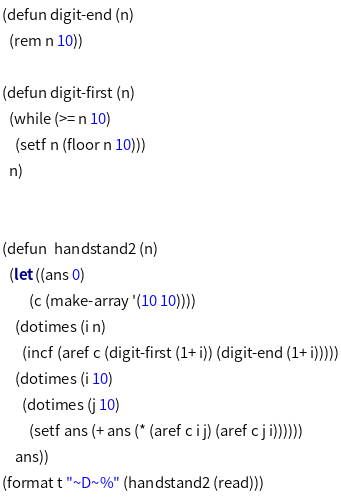Convert code to text. <code><loc_0><loc_0><loc_500><loc_500><_Lisp_>(defun digit-end (n)
  (rem n 10))

(defun digit-first (n)
  (while (>= n 10)
    (setf n (floor n 10)))
  n)


(defun  handstand2 (n)
  (let ((ans 0)
        (c (make-array '(10 10))))
    (dotimes (i n)
      (incf (aref c (digit-first (1+ i)) (digit-end (1+ i)))))
    (dotimes (i 10)
      (dotimes (j 10)
        (setf ans (+ ans (* (aref c i j) (aref c j i))))))
    ans))
(format t "~D~%" (handstand2 (read))) 
</code> 